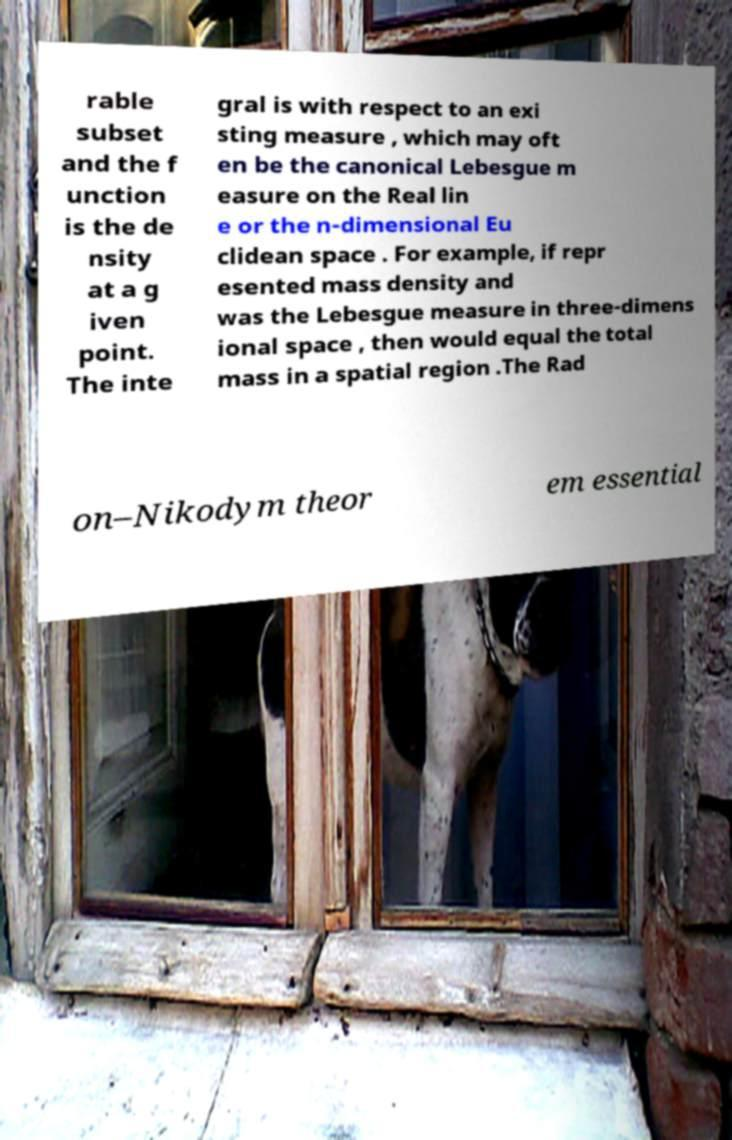For documentation purposes, I need the text within this image transcribed. Could you provide that? rable subset and the f unction is the de nsity at a g iven point. The inte gral is with respect to an exi sting measure , which may oft en be the canonical Lebesgue m easure on the Real lin e or the n-dimensional Eu clidean space . For example, if repr esented mass density and was the Lebesgue measure in three-dimens ional space , then would equal the total mass in a spatial region .The Rad on–Nikodym theor em essential 